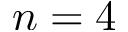<formula> <loc_0><loc_0><loc_500><loc_500>n = 4</formula> 